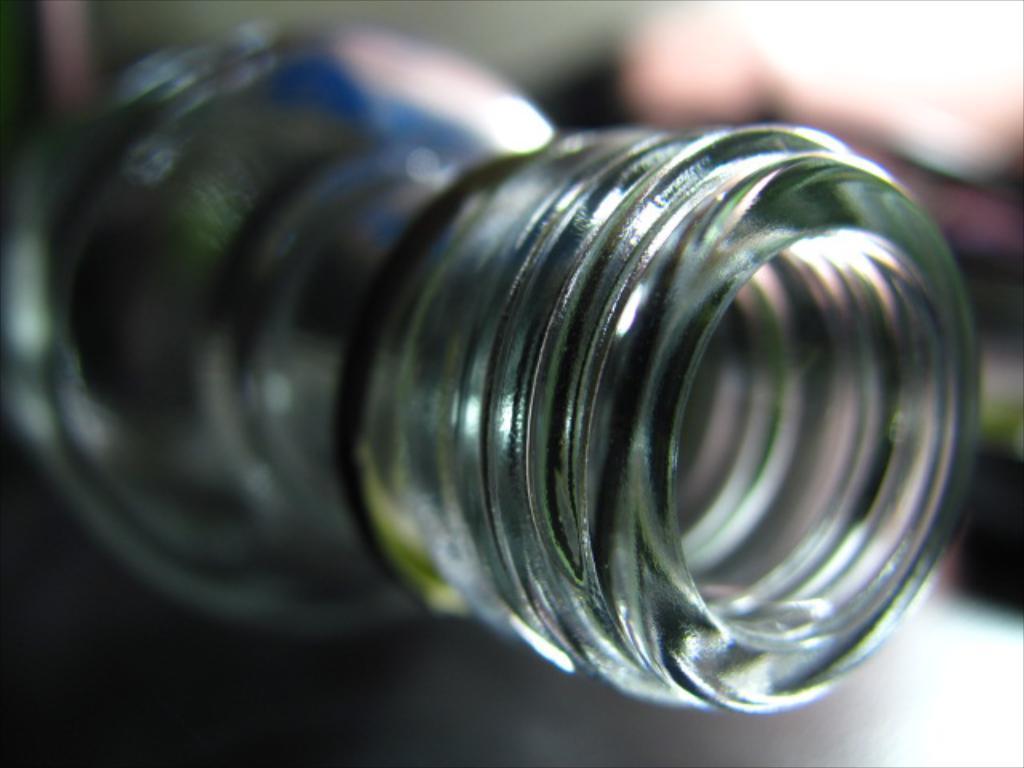Can you describe this image briefly? This is a opening of a bottle. 